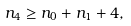Convert formula to latex. <formula><loc_0><loc_0><loc_500><loc_500>n _ { 4 } \geq n _ { 0 } + n _ { 1 } + 4 ,</formula> 